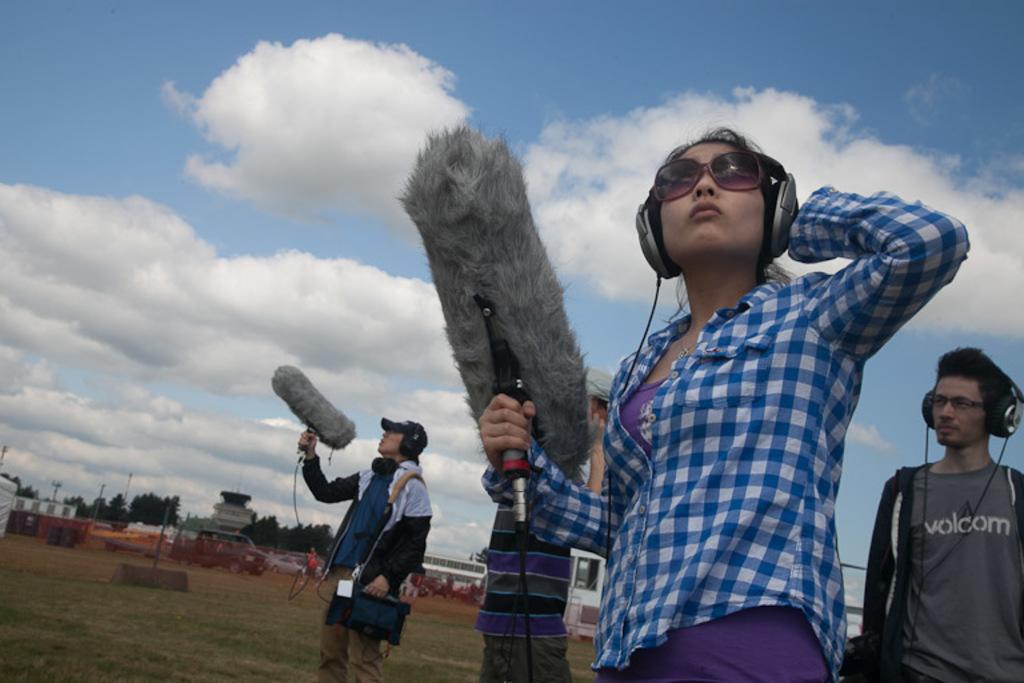Please provide a concise description of this image. In this picture we can see persons,vehicles on the ground and in the background we can see trees,sky. 